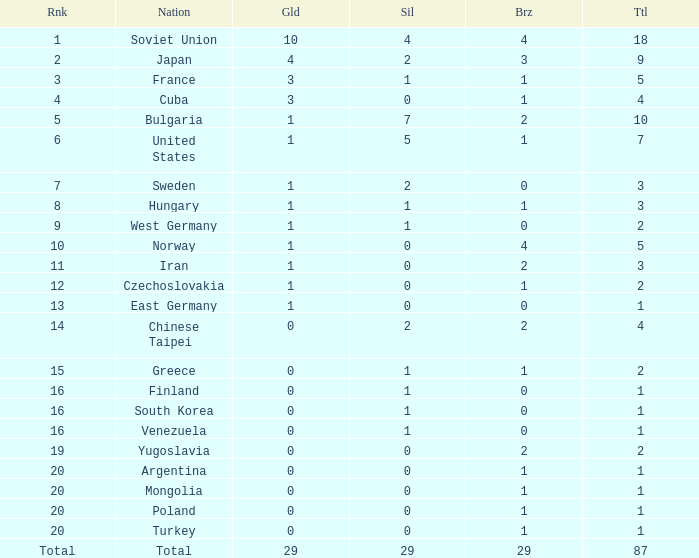What is the sum of gold medals for a rank of 14? 0.0. 